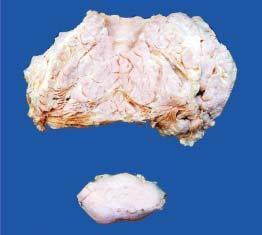what does lower part of the image show?
Answer the question using a single word or phrase. A separate encapsulated gelatinous mass 